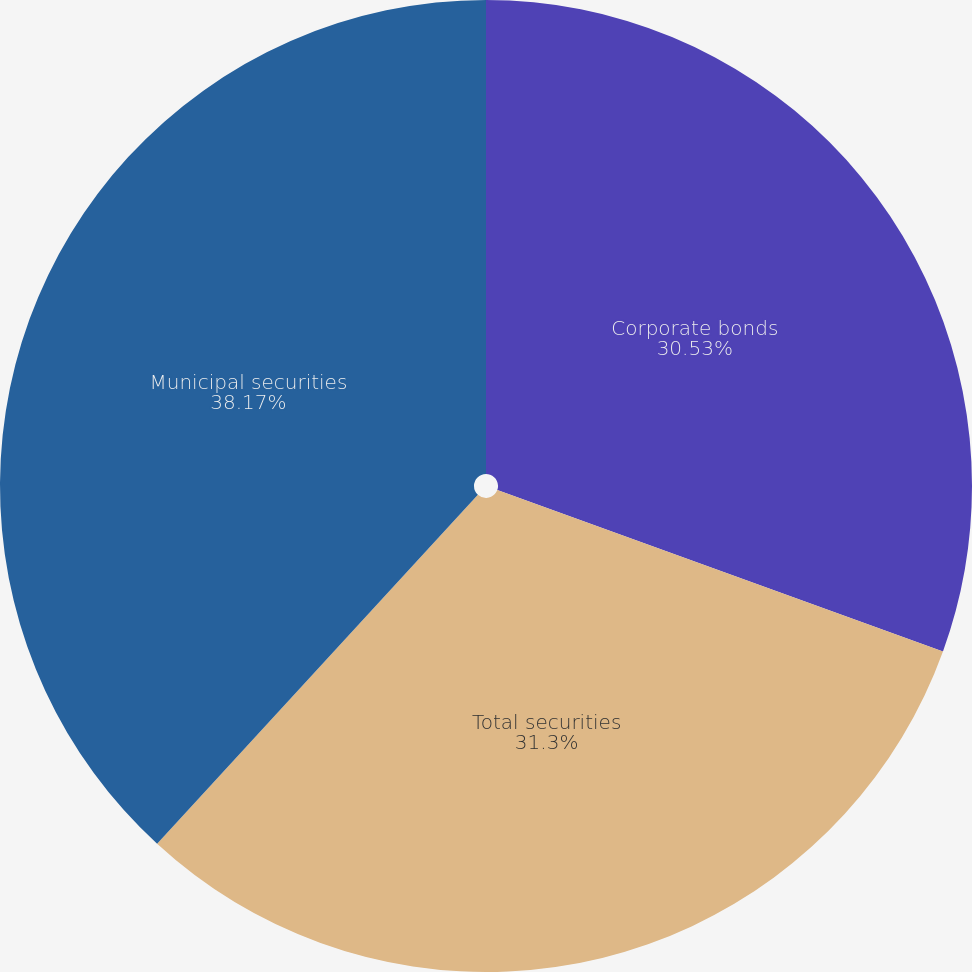Convert chart to OTSL. <chart><loc_0><loc_0><loc_500><loc_500><pie_chart><fcel>Corporate bonds<fcel>Total securities<fcel>Municipal securities<nl><fcel>30.53%<fcel>31.3%<fcel>38.17%<nl></chart> 